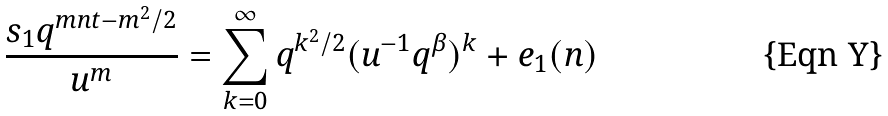Convert formula to latex. <formula><loc_0><loc_0><loc_500><loc_500>\frac { s _ { 1 } q ^ { m n t - m ^ { 2 } / 2 } } { u ^ { m } } = \sum _ { k = 0 } ^ { \infty } q ^ { k ^ { 2 } / 2 } ( u ^ { - 1 } q ^ { \beta } ) ^ { k } + e _ { 1 } ( n )</formula> 